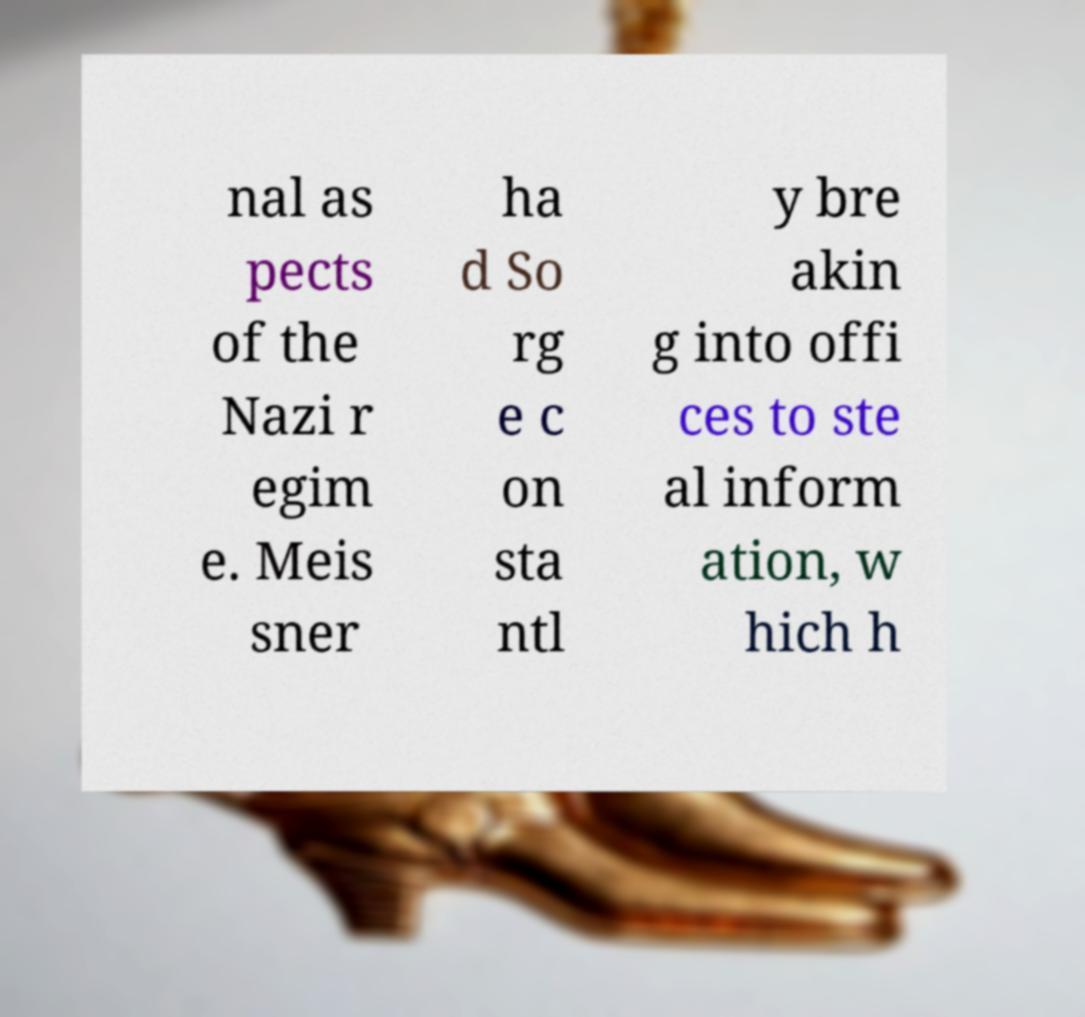Please identify and transcribe the text found in this image. nal as pects of the Nazi r egim e. Meis sner ha d So rg e c on sta ntl y bre akin g into offi ces to ste al inform ation, w hich h 